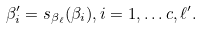Convert formula to latex. <formula><loc_0><loc_0><loc_500><loc_500>\beta _ { i } ^ { \prime } = s _ { \beta _ { \ell } } ( \beta _ { i } ) , i = 1 , \dots c , \ell ^ { \prime } .</formula> 